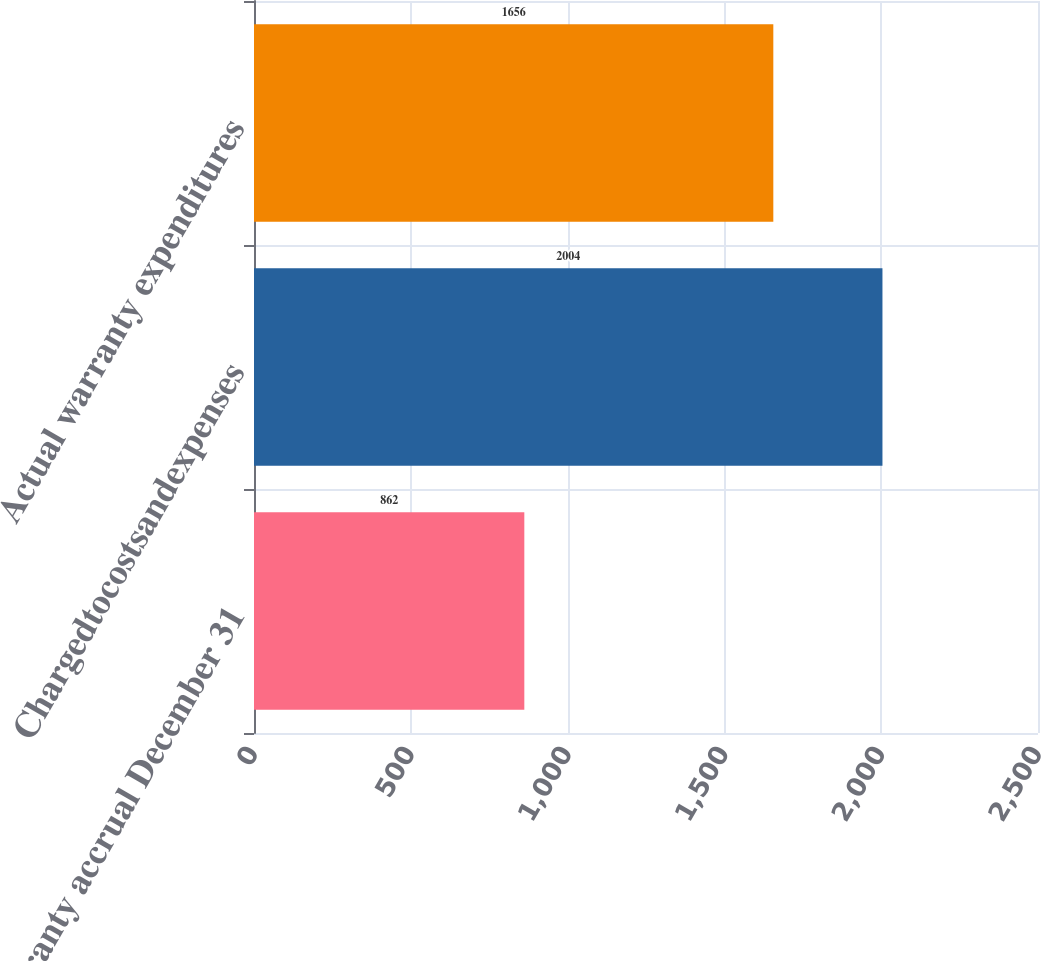Convert chart to OTSL. <chart><loc_0><loc_0><loc_500><loc_500><bar_chart><fcel>Warranty accrual December 31<fcel>Chargedtocostsandexpenses<fcel>Actual warranty expenditures<nl><fcel>862<fcel>2004<fcel>1656<nl></chart> 